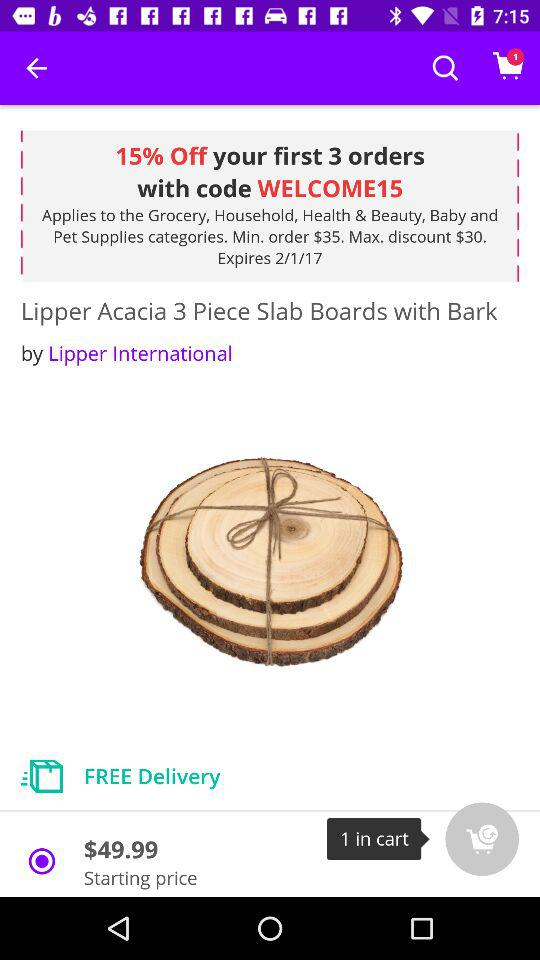How many items are in the cart?
Answer the question using a single word or phrase. 1 